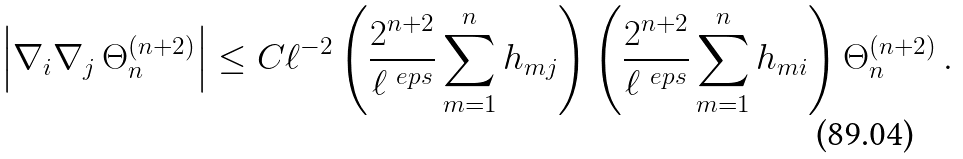<formula> <loc_0><loc_0><loc_500><loc_500>\left | \nabla _ { i } \nabla _ { j } \, \Theta _ { n } ^ { ( n + 2 ) } \right | \leq C \ell ^ { - 2 } \left ( \frac { 2 ^ { n + 2 } } { \ell ^ { \ e p s } } \sum _ { m = 1 } ^ { n } h _ { m j } \right ) \left ( \frac { 2 ^ { n + 2 } } { \ell ^ { \ e p s } } \sum _ { m = 1 } ^ { n } h _ { m i } \right ) \Theta _ { n } ^ { ( n + 2 ) } \, .</formula> 